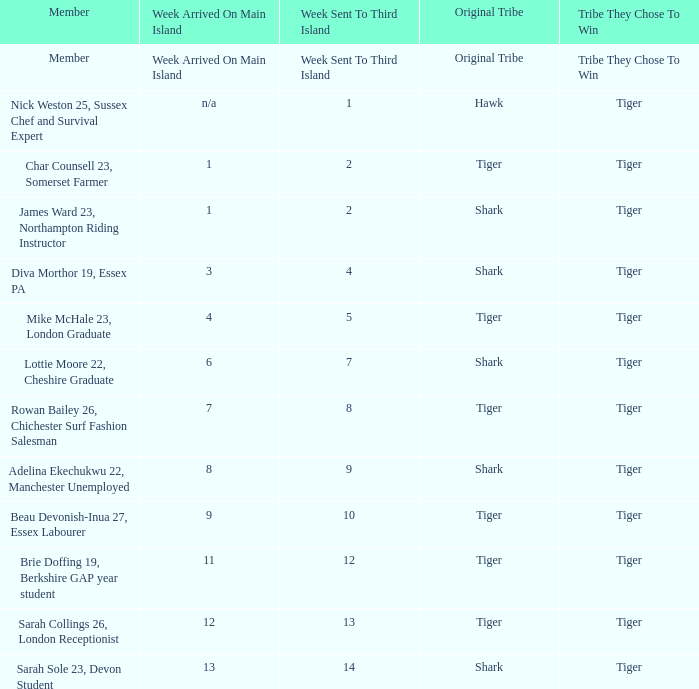Who was sent to the third island in week 1? Nick Weston 25, Sussex Chef and Survival Expert. 